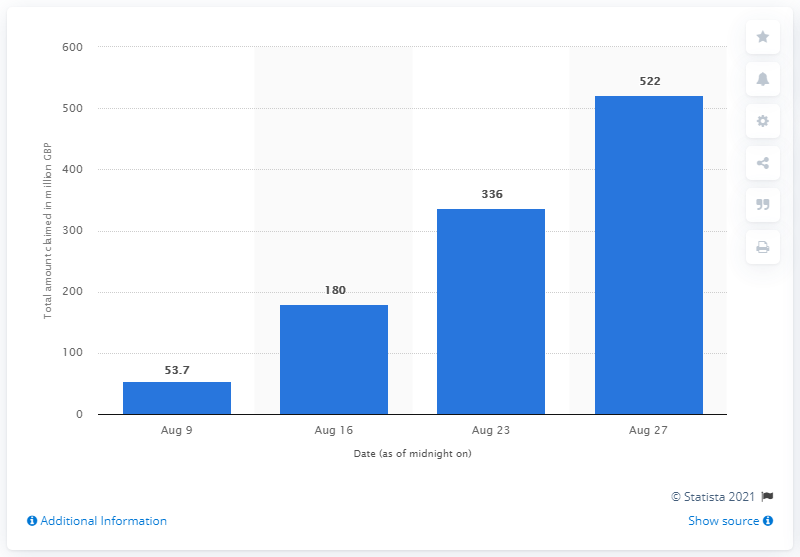Indicate a few pertinent items in this graphic. The 'Eat Out to Help Out Scheme' had reimbursed a total of 522 pounds to participating restaurants. 